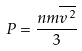<formula> <loc_0><loc_0><loc_500><loc_500>P = \frac { n m \overline { v ^ { 2 } } } { 3 }</formula> 